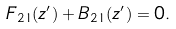<formula> <loc_0><loc_0><loc_500><loc_500>F _ { 2 1 } ( z ^ { \prime } ) + B _ { 2 1 } ( z ^ { \prime } ) = 0 .</formula> 